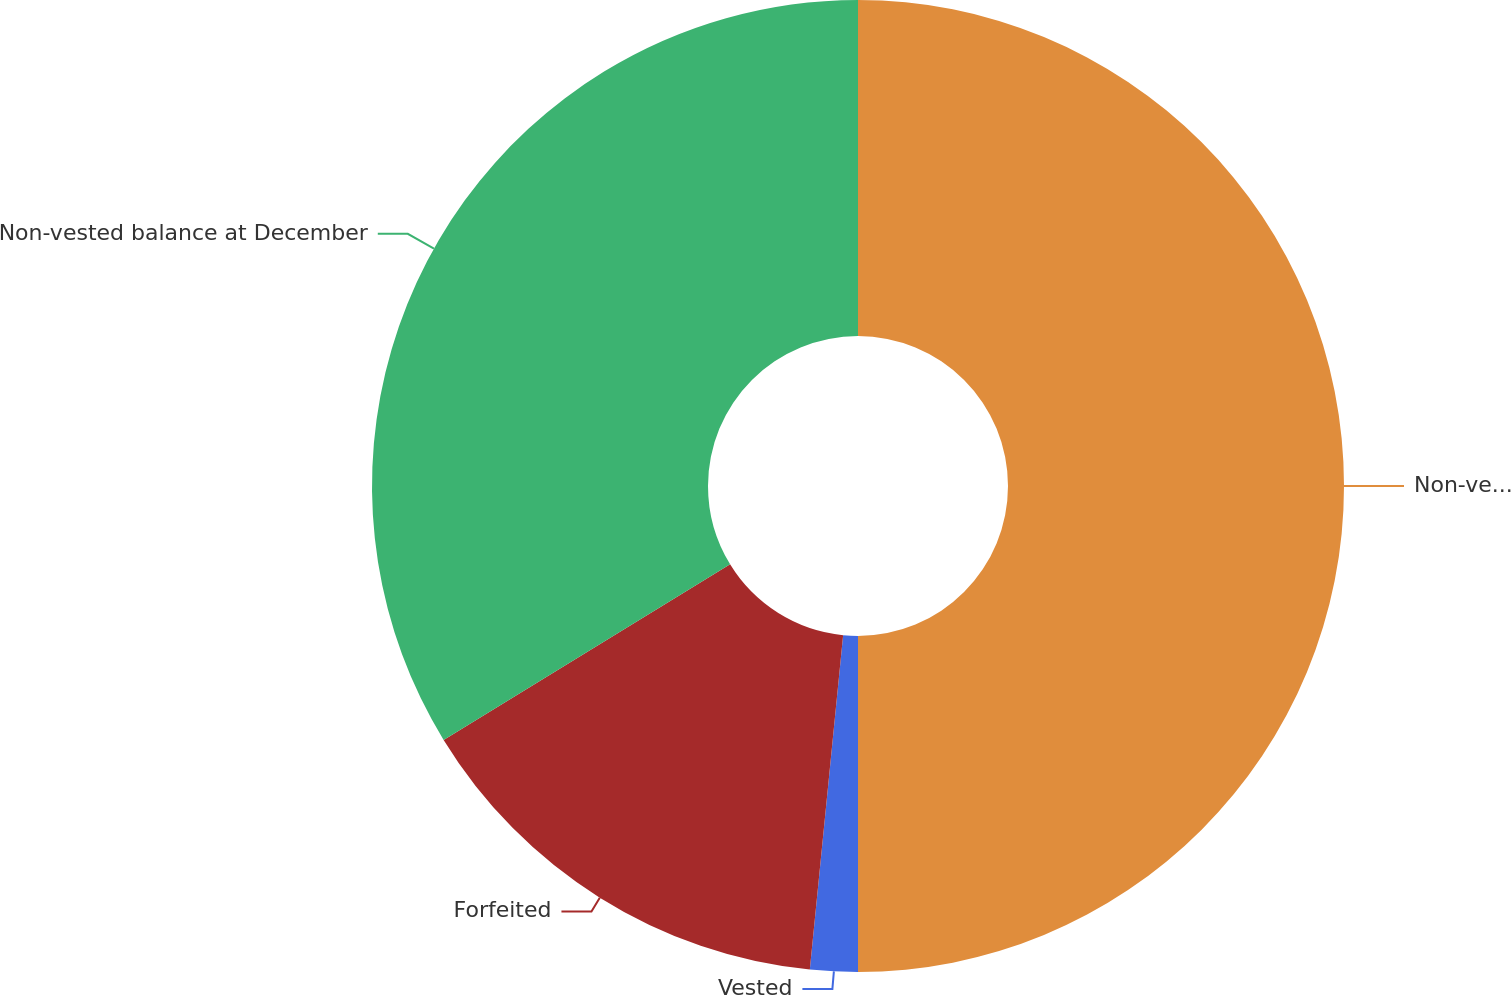Convert chart to OTSL. <chart><loc_0><loc_0><loc_500><loc_500><pie_chart><fcel>Non-vested balance at January<fcel>Vested<fcel>Forfeited<fcel>Non-vested balance at December<nl><fcel>50.0%<fcel>1.58%<fcel>14.67%<fcel>33.75%<nl></chart> 